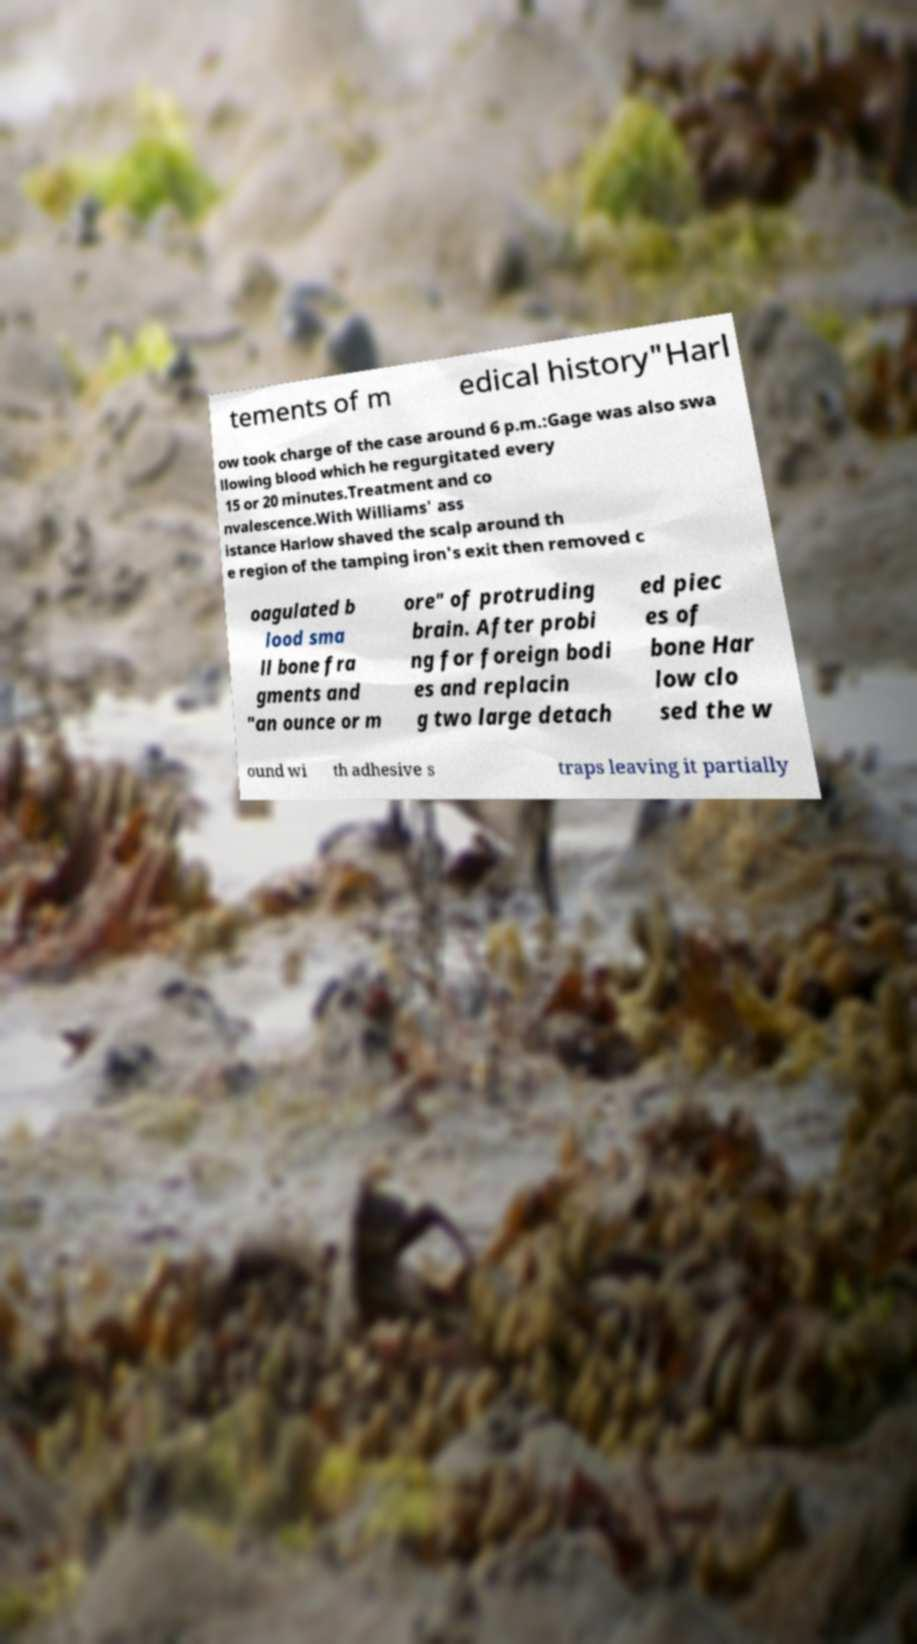Please read and relay the text visible in this image. What does it say? tements of m edical history"Harl ow took charge of the case around 6 p.m.:Gage was also swa llowing blood which he regurgitated every 15 or 20 minutes.Treatment and co nvalescence.With Williams' ass istance Harlow shaved the scalp around th e region of the tamping iron's exit then removed c oagulated b lood sma ll bone fra gments and "an ounce or m ore" of protruding brain. After probi ng for foreign bodi es and replacin g two large detach ed piec es of bone Har low clo sed the w ound wi th adhesive s traps leaving it partially 